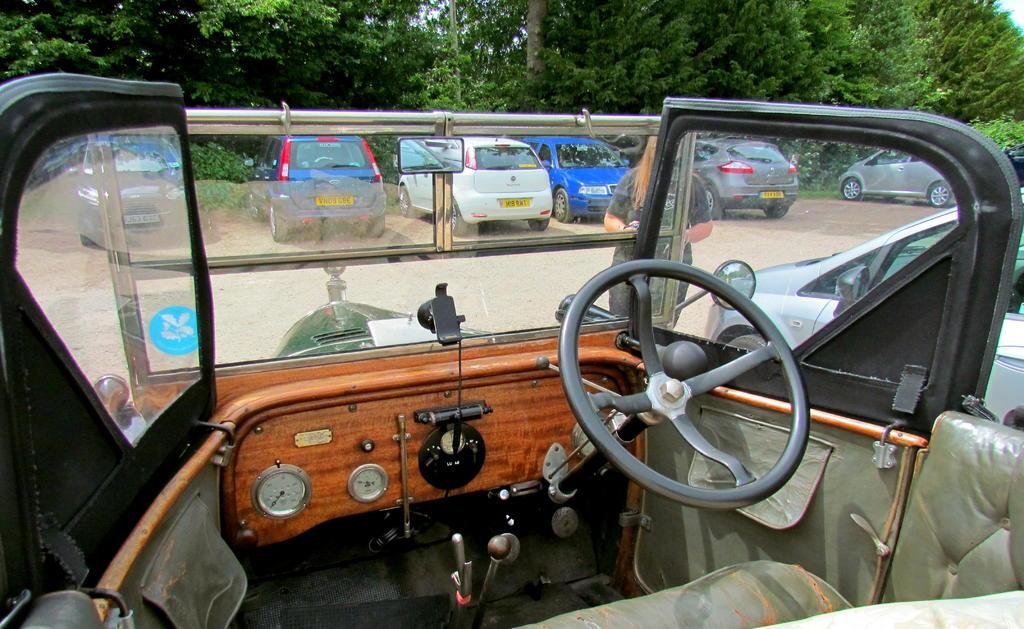What types of objects can be seen in the image? There are vehicles in the image. What natural elements are present in the image? There are trees in the image. What part of the environment is visible in the image? The sky is visible in the image. How do the ants use the glue to survive the earthquake in the image? There are no ants, glue, or earthquake present in the image. 